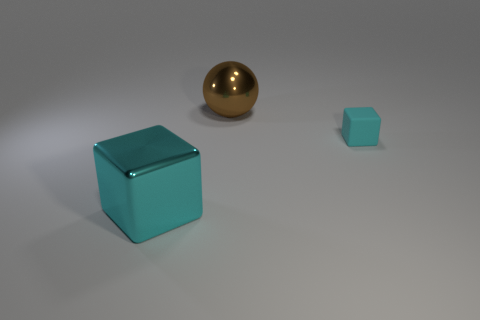What number of cyan cubes are the same size as the brown shiny sphere?
Provide a succinct answer. 1. Is the material of the block that is to the left of the tiny cyan cube the same as the cyan object that is right of the brown metallic sphere?
Keep it short and to the point. No. Is there any other thing that is the same shape as the small cyan rubber thing?
Provide a succinct answer. Yes. What is the color of the large ball?
Provide a short and direct response. Brown. What number of other things are the same shape as the small matte object?
Provide a succinct answer. 1. The metal cube that is the same size as the brown shiny sphere is what color?
Provide a short and direct response. Cyan. Are any tiny objects visible?
Provide a short and direct response. Yes. There is a large metal object behind the cyan metallic cube; what shape is it?
Your response must be concise. Sphere. How many things are both in front of the brown object and behind the large cube?
Provide a short and direct response. 1. Is there a cyan cube that has the same material as the sphere?
Make the answer very short. Yes. 